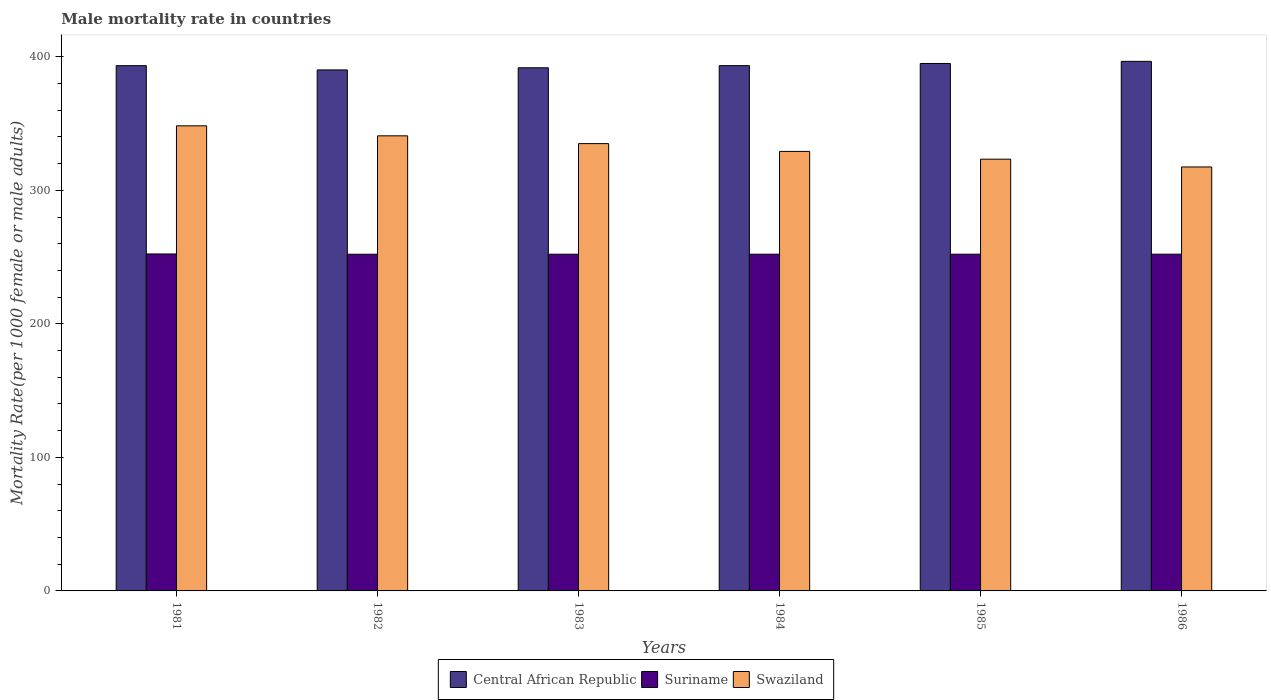How many groups of bars are there?
Offer a very short reply. 6. Are the number of bars on each tick of the X-axis equal?
Provide a succinct answer. Yes. How many bars are there on the 2nd tick from the left?
Your answer should be compact. 3. How many bars are there on the 3rd tick from the right?
Give a very brief answer. 3. What is the male mortality rate in Central African Republic in 1985?
Your response must be concise. 395. Across all years, what is the maximum male mortality rate in Suriname?
Your answer should be very brief. 252.35. Across all years, what is the minimum male mortality rate in Central African Republic?
Provide a succinct answer. 390.2. In which year was the male mortality rate in Suriname minimum?
Offer a terse response. 1982. What is the total male mortality rate in Central African Republic in the graph?
Keep it short and to the point. 2360.39. What is the difference between the male mortality rate in Central African Republic in 1981 and that in 1983?
Ensure brevity in your answer.  1.58. What is the difference between the male mortality rate in Swaziland in 1986 and the male mortality rate in Central African Republic in 1985?
Your answer should be very brief. -77.5. What is the average male mortality rate in Central African Republic per year?
Make the answer very short. 393.4. In the year 1986, what is the difference between the male mortality rate in Swaziland and male mortality rate in Suriname?
Offer a terse response. 65.32. What is the ratio of the male mortality rate in Swaziland in 1981 to that in 1985?
Give a very brief answer. 1.08. Is the male mortality rate in Suriname in 1984 less than that in 1986?
Your answer should be compact. Yes. What is the difference between the highest and the second highest male mortality rate in Swaziland?
Make the answer very short. 7.51. What is the difference between the highest and the lowest male mortality rate in Suriname?
Offer a very short reply. 0.21. Is the sum of the male mortality rate in Central African Republic in 1981 and 1986 greater than the maximum male mortality rate in Suriname across all years?
Ensure brevity in your answer.  Yes. What does the 3rd bar from the left in 1981 represents?
Offer a very short reply. Swaziland. What does the 2nd bar from the right in 1986 represents?
Offer a terse response. Suriname. Are all the bars in the graph horizontal?
Keep it short and to the point. No. How many years are there in the graph?
Provide a short and direct response. 6. How many legend labels are there?
Offer a very short reply. 3. How are the legend labels stacked?
Keep it short and to the point. Horizontal. What is the title of the graph?
Give a very brief answer. Male mortality rate in countries. Does "Senegal" appear as one of the legend labels in the graph?
Offer a very short reply. No. What is the label or title of the Y-axis?
Provide a succinct answer. Mortality Rate(per 1000 female or male adults). What is the Mortality Rate(per 1000 female or male adults) in Central African Republic in 1981?
Ensure brevity in your answer.  393.38. What is the Mortality Rate(per 1000 female or male adults) in Suriname in 1981?
Offer a terse response. 252.35. What is the Mortality Rate(per 1000 female or male adults) in Swaziland in 1981?
Keep it short and to the point. 348.33. What is the Mortality Rate(per 1000 female or male adults) of Central African Republic in 1982?
Your answer should be compact. 390.2. What is the Mortality Rate(per 1000 female or male adults) of Suriname in 1982?
Your answer should be compact. 252.15. What is the Mortality Rate(per 1000 female or male adults) of Swaziland in 1982?
Give a very brief answer. 340.82. What is the Mortality Rate(per 1000 female or male adults) in Central African Republic in 1983?
Offer a very short reply. 391.8. What is the Mortality Rate(per 1000 female or male adults) of Suriname in 1983?
Your answer should be compact. 252.16. What is the Mortality Rate(per 1000 female or male adults) in Swaziland in 1983?
Offer a very short reply. 334.99. What is the Mortality Rate(per 1000 female or male adults) of Central African Republic in 1984?
Your answer should be very brief. 393.4. What is the Mortality Rate(per 1000 female or male adults) in Suriname in 1984?
Your answer should be very brief. 252.17. What is the Mortality Rate(per 1000 female or male adults) in Swaziland in 1984?
Ensure brevity in your answer.  329.16. What is the Mortality Rate(per 1000 female or male adults) in Central African Republic in 1985?
Your answer should be compact. 395. What is the Mortality Rate(per 1000 female or male adults) in Suriname in 1985?
Ensure brevity in your answer.  252.18. What is the Mortality Rate(per 1000 female or male adults) in Swaziland in 1985?
Keep it short and to the point. 323.33. What is the Mortality Rate(per 1000 female or male adults) in Central African Republic in 1986?
Your answer should be very brief. 396.6. What is the Mortality Rate(per 1000 female or male adults) of Suriname in 1986?
Provide a succinct answer. 252.19. What is the Mortality Rate(per 1000 female or male adults) in Swaziland in 1986?
Your response must be concise. 317.51. Across all years, what is the maximum Mortality Rate(per 1000 female or male adults) in Central African Republic?
Offer a very short reply. 396.6. Across all years, what is the maximum Mortality Rate(per 1000 female or male adults) in Suriname?
Your answer should be compact. 252.35. Across all years, what is the maximum Mortality Rate(per 1000 female or male adults) of Swaziland?
Provide a succinct answer. 348.33. Across all years, what is the minimum Mortality Rate(per 1000 female or male adults) of Central African Republic?
Ensure brevity in your answer.  390.2. Across all years, what is the minimum Mortality Rate(per 1000 female or male adults) in Suriname?
Offer a very short reply. 252.15. Across all years, what is the minimum Mortality Rate(per 1000 female or male adults) in Swaziland?
Provide a short and direct response. 317.51. What is the total Mortality Rate(per 1000 female or male adults) of Central African Republic in the graph?
Ensure brevity in your answer.  2360.39. What is the total Mortality Rate(per 1000 female or male adults) in Suriname in the graph?
Make the answer very short. 1513.19. What is the total Mortality Rate(per 1000 female or male adults) in Swaziland in the graph?
Give a very brief answer. 1994.14. What is the difference between the Mortality Rate(per 1000 female or male adults) in Central African Republic in 1981 and that in 1982?
Offer a terse response. 3.18. What is the difference between the Mortality Rate(per 1000 female or male adults) of Suriname in 1981 and that in 1982?
Provide a short and direct response. 0.21. What is the difference between the Mortality Rate(per 1000 female or male adults) of Swaziland in 1981 and that in 1982?
Keep it short and to the point. 7.51. What is the difference between the Mortality Rate(per 1000 female or male adults) in Central African Republic in 1981 and that in 1983?
Keep it short and to the point. 1.58. What is the difference between the Mortality Rate(per 1000 female or male adults) in Suriname in 1981 and that in 1983?
Make the answer very short. 0.2. What is the difference between the Mortality Rate(per 1000 female or male adults) of Swaziland in 1981 and that in 1983?
Your answer should be very brief. 13.34. What is the difference between the Mortality Rate(per 1000 female or male adults) in Central African Republic in 1981 and that in 1984?
Your answer should be compact. -0.02. What is the difference between the Mortality Rate(per 1000 female or male adults) of Suriname in 1981 and that in 1984?
Offer a terse response. 0.19. What is the difference between the Mortality Rate(per 1000 female or male adults) in Swaziland in 1981 and that in 1984?
Offer a terse response. 19.16. What is the difference between the Mortality Rate(per 1000 female or male adults) in Central African Republic in 1981 and that in 1985?
Give a very brief answer. -1.62. What is the difference between the Mortality Rate(per 1000 female or male adults) of Suriname in 1981 and that in 1985?
Offer a terse response. 0.18. What is the difference between the Mortality Rate(per 1000 female or male adults) of Swaziland in 1981 and that in 1985?
Your response must be concise. 24.99. What is the difference between the Mortality Rate(per 1000 female or male adults) of Central African Republic in 1981 and that in 1986?
Your response must be concise. -3.22. What is the difference between the Mortality Rate(per 1000 female or male adults) of Suriname in 1981 and that in 1986?
Provide a succinct answer. 0.17. What is the difference between the Mortality Rate(per 1000 female or male adults) in Swaziland in 1981 and that in 1986?
Give a very brief answer. 30.82. What is the difference between the Mortality Rate(per 1000 female or male adults) of Central African Republic in 1982 and that in 1983?
Your answer should be very brief. -1.6. What is the difference between the Mortality Rate(per 1000 female or male adults) in Suriname in 1982 and that in 1983?
Provide a succinct answer. -0.01. What is the difference between the Mortality Rate(per 1000 female or male adults) of Swaziland in 1982 and that in 1983?
Make the answer very short. 5.83. What is the difference between the Mortality Rate(per 1000 female or male adults) of Central African Republic in 1982 and that in 1984?
Provide a short and direct response. -3.2. What is the difference between the Mortality Rate(per 1000 female or male adults) in Suriname in 1982 and that in 1984?
Offer a terse response. -0.02. What is the difference between the Mortality Rate(per 1000 female or male adults) in Swaziland in 1982 and that in 1984?
Offer a very short reply. 11.66. What is the difference between the Mortality Rate(per 1000 female or male adults) in Central African Republic in 1982 and that in 1985?
Provide a succinct answer. -4.8. What is the difference between the Mortality Rate(per 1000 female or male adults) of Suriname in 1982 and that in 1985?
Offer a terse response. -0.03. What is the difference between the Mortality Rate(per 1000 female or male adults) of Swaziland in 1982 and that in 1985?
Make the answer very short. 17.48. What is the difference between the Mortality Rate(per 1000 female or male adults) of Central African Republic in 1982 and that in 1986?
Offer a terse response. -6.41. What is the difference between the Mortality Rate(per 1000 female or male adults) of Suriname in 1982 and that in 1986?
Ensure brevity in your answer.  -0.04. What is the difference between the Mortality Rate(per 1000 female or male adults) of Swaziland in 1982 and that in 1986?
Offer a very short reply. 23.31. What is the difference between the Mortality Rate(per 1000 female or male adults) of Central African Republic in 1983 and that in 1984?
Ensure brevity in your answer.  -1.6. What is the difference between the Mortality Rate(per 1000 female or male adults) of Suriname in 1983 and that in 1984?
Provide a succinct answer. -0.01. What is the difference between the Mortality Rate(per 1000 female or male adults) in Swaziland in 1983 and that in 1984?
Your response must be concise. 5.83. What is the difference between the Mortality Rate(per 1000 female or male adults) in Central African Republic in 1983 and that in 1985?
Provide a succinct answer. -3.2. What is the difference between the Mortality Rate(per 1000 female or male adults) in Suriname in 1983 and that in 1985?
Provide a short and direct response. -0.02. What is the difference between the Mortality Rate(per 1000 female or male adults) in Swaziland in 1983 and that in 1985?
Keep it short and to the point. 11.65. What is the difference between the Mortality Rate(per 1000 female or male adults) of Central African Republic in 1983 and that in 1986?
Keep it short and to the point. -4.8. What is the difference between the Mortality Rate(per 1000 female or male adults) of Suriname in 1983 and that in 1986?
Make the answer very short. -0.03. What is the difference between the Mortality Rate(per 1000 female or male adults) in Swaziland in 1983 and that in 1986?
Your answer should be very brief. 17.48. What is the difference between the Mortality Rate(per 1000 female or male adults) of Central African Republic in 1984 and that in 1985?
Offer a terse response. -1.6. What is the difference between the Mortality Rate(per 1000 female or male adults) in Suriname in 1984 and that in 1985?
Your answer should be very brief. -0.01. What is the difference between the Mortality Rate(per 1000 female or male adults) in Swaziland in 1984 and that in 1985?
Give a very brief answer. 5.83. What is the difference between the Mortality Rate(per 1000 female or male adults) in Central African Republic in 1984 and that in 1986?
Offer a very short reply. -3.2. What is the difference between the Mortality Rate(per 1000 female or male adults) of Suriname in 1984 and that in 1986?
Offer a very short reply. -0.02. What is the difference between the Mortality Rate(per 1000 female or male adults) of Swaziland in 1984 and that in 1986?
Offer a terse response. 11.65. What is the difference between the Mortality Rate(per 1000 female or male adults) in Central African Republic in 1985 and that in 1986?
Ensure brevity in your answer.  -1.6. What is the difference between the Mortality Rate(per 1000 female or male adults) of Suriname in 1985 and that in 1986?
Make the answer very short. -0.01. What is the difference between the Mortality Rate(per 1000 female or male adults) in Swaziland in 1985 and that in 1986?
Give a very brief answer. 5.83. What is the difference between the Mortality Rate(per 1000 female or male adults) in Central African Republic in 1981 and the Mortality Rate(per 1000 female or male adults) in Suriname in 1982?
Give a very brief answer. 141.24. What is the difference between the Mortality Rate(per 1000 female or male adults) in Central African Republic in 1981 and the Mortality Rate(per 1000 female or male adults) in Swaziland in 1982?
Give a very brief answer. 52.56. What is the difference between the Mortality Rate(per 1000 female or male adults) of Suriname in 1981 and the Mortality Rate(per 1000 female or male adults) of Swaziland in 1982?
Make the answer very short. -88.46. What is the difference between the Mortality Rate(per 1000 female or male adults) of Central African Republic in 1981 and the Mortality Rate(per 1000 female or male adults) of Suriname in 1983?
Your answer should be compact. 141.22. What is the difference between the Mortality Rate(per 1000 female or male adults) of Central African Republic in 1981 and the Mortality Rate(per 1000 female or male adults) of Swaziland in 1983?
Offer a very short reply. 58.39. What is the difference between the Mortality Rate(per 1000 female or male adults) in Suriname in 1981 and the Mortality Rate(per 1000 female or male adults) in Swaziland in 1983?
Keep it short and to the point. -82.64. What is the difference between the Mortality Rate(per 1000 female or male adults) in Central African Republic in 1981 and the Mortality Rate(per 1000 female or male adults) in Suriname in 1984?
Provide a short and direct response. 141.21. What is the difference between the Mortality Rate(per 1000 female or male adults) in Central African Republic in 1981 and the Mortality Rate(per 1000 female or male adults) in Swaziland in 1984?
Provide a succinct answer. 64.22. What is the difference between the Mortality Rate(per 1000 female or male adults) in Suriname in 1981 and the Mortality Rate(per 1000 female or male adults) in Swaziland in 1984?
Provide a short and direct response. -76.81. What is the difference between the Mortality Rate(per 1000 female or male adults) of Central African Republic in 1981 and the Mortality Rate(per 1000 female or male adults) of Suriname in 1985?
Make the answer very short. 141.2. What is the difference between the Mortality Rate(per 1000 female or male adults) in Central African Republic in 1981 and the Mortality Rate(per 1000 female or male adults) in Swaziland in 1985?
Provide a short and direct response. 70.05. What is the difference between the Mortality Rate(per 1000 female or male adults) in Suriname in 1981 and the Mortality Rate(per 1000 female or male adults) in Swaziland in 1985?
Your answer should be very brief. -70.98. What is the difference between the Mortality Rate(per 1000 female or male adults) in Central African Republic in 1981 and the Mortality Rate(per 1000 female or male adults) in Suriname in 1986?
Your answer should be compact. 141.19. What is the difference between the Mortality Rate(per 1000 female or male adults) of Central African Republic in 1981 and the Mortality Rate(per 1000 female or male adults) of Swaziland in 1986?
Keep it short and to the point. 75.87. What is the difference between the Mortality Rate(per 1000 female or male adults) in Suriname in 1981 and the Mortality Rate(per 1000 female or male adults) in Swaziland in 1986?
Ensure brevity in your answer.  -65.15. What is the difference between the Mortality Rate(per 1000 female or male adults) in Central African Republic in 1982 and the Mortality Rate(per 1000 female or male adults) in Suriname in 1983?
Keep it short and to the point. 138.04. What is the difference between the Mortality Rate(per 1000 female or male adults) of Central African Republic in 1982 and the Mortality Rate(per 1000 female or male adults) of Swaziland in 1983?
Offer a terse response. 55.21. What is the difference between the Mortality Rate(per 1000 female or male adults) of Suriname in 1982 and the Mortality Rate(per 1000 female or male adults) of Swaziland in 1983?
Your answer should be very brief. -82.84. What is the difference between the Mortality Rate(per 1000 female or male adults) of Central African Republic in 1982 and the Mortality Rate(per 1000 female or male adults) of Suriname in 1984?
Give a very brief answer. 138.03. What is the difference between the Mortality Rate(per 1000 female or male adults) in Central African Republic in 1982 and the Mortality Rate(per 1000 female or male adults) in Swaziland in 1984?
Make the answer very short. 61.04. What is the difference between the Mortality Rate(per 1000 female or male adults) in Suriname in 1982 and the Mortality Rate(per 1000 female or male adults) in Swaziland in 1984?
Make the answer very short. -77.02. What is the difference between the Mortality Rate(per 1000 female or male adults) of Central African Republic in 1982 and the Mortality Rate(per 1000 female or male adults) of Suriname in 1985?
Offer a terse response. 138.02. What is the difference between the Mortality Rate(per 1000 female or male adults) in Central African Republic in 1982 and the Mortality Rate(per 1000 female or male adults) in Swaziland in 1985?
Offer a very short reply. 66.86. What is the difference between the Mortality Rate(per 1000 female or male adults) in Suriname in 1982 and the Mortality Rate(per 1000 female or male adults) in Swaziland in 1985?
Provide a short and direct response. -71.19. What is the difference between the Mortality Rate(per 1000 female or male adults) of Central African Republic in 1982 and the Mortality Rate(per 1000 female or male adults) of Suriname in 1986?
Make the answer very short. 138.01. What is the difference between the Mortality Rate(per 1000 female or male adults) of Central African Republic in 1982 and the Mortality Rate(per 1000 female or male adults) of Swaziland in 1986?
Provide a short and direct response. 72.69. What is the difference between the Mortality Rate(per 1000 female or male adults) in Suriname in 1982 and the Mortality Rate(per 1000 female or male adults) in Swaziland in 1986?
Give a very brief answer. -65.36. What is the difference between the Mortality Rate(per 1000 female or male adults) in Central African Republic in 1983 and the Mortality Rate(per 1000 female or male adults) in Suriname in 1984?
Provide a succinct answer. 139.63. What is the difference between the Mortality Rate(per 1000 female or male adults) in Central African Republic in 1983 and the Mortality Rate(per 1000 female or male adults) in Swaziland in 1984?
Ensure brevity in your answer.  62.64. What is the difference between the Mortality Rate(per 1000 female or male adults) of Suriname in 1983 and the Mortality Rate(per 1000 female or male adults) of Swaziland in 1984?
Keep it short and to the point. -77. What is the difference between the Mortality Rate(per 1000 female or male adults) in Central African Republic in 1983 and the Mortality Rate(per 1000 female or male adults) in Suriname in 1985?
Provide a short and direct response. 139.62. What is the difference between the Mortality Rate(per 1000 female or male adults) of Central African Republic in 1983 and the Mortality Rate(per 1000 female or male adults) of Swaziland in 1985?
Give a very brief answer. 68.47. What is the difference between the Mortality Rate(per 1000 female or male adults) of Suriname in 1983 and the Mortality Rate(per 1000 female or male adults) of Swaziland in 1985?
Make the answer very short. -71.18. What is the difference between the Mortality Rate(per 1000 female or male adults) of Central African Republic in 1983 and the Mortality Rate(per 1000 female or male adults) of Suriname in 1986?
Your answer should be compact. 139.61. What is the difference between the Mortality Rate(per 1000 female or male adults) of Central African Republic in 1983 and the Mortality Rate(per 1000 female or male adults) of Swaziland in 1986?
Offer a terse response. 74.29. What is the difference between the Mortality Rate(per 1000 female or male adults) of Suriname in 1983 and the Mortality Rate(per 1000 female or male adults) of Swaziland in 1986?
Make the answer very short. -65.35. What is the difference between the Mortality Rate(per 1000 female or male adults) of Central African Republic in 1984 and the Mortality Rate(per 1000 female or male adults) of Suriname in 1985?
Give a very brief answer. 141.22. What is the difference between the Mortality Rate(per 1000 female or male adults) in Central African Republic in 1984 and the Mortality Rate(per 1000 female or male adults) in Swaziland in 1985?
Provide a succinct answer. 70.07. What is the difference between the Mortality Rate(per 1000 female or male adults) of Suriname in 1984 and the Mortality Rate(per 1000 female or male adults) of Swaziland in 1985?
Give a very brief answer. -71.17. What is the difference between the Mortality Rate(per 1000 female or male adults) of Central African Republic in 1984 and the Mortality Rate(per 1000 female or male adults) of Suriname in 1986?
Your response must be concise. 141.21. What is the difference between the Mortality Rate(per 1000 female or male adults) in Central African Republic in 1984 and the Mortality Rate(per 1000 female or male adults) in Swaziland in 1986?
Provide a short and direct response. 75.89. What is the difference between the Mortality Rate(per 1000 female or male adults) in Suriname in 1984 and the Mortality Rate(per 1000 female or male adults) in Swaziland in 1986?
Give a very brief answer. -65.34. What is the difference between the Mortality Rate(per 1000 female or male adults) of Central African Republic in 1985 and the Mortality Rate(per 1000 female or male adults) of Suriname in 1986?
Give a very brief answer. 142.81. What is the difference between the Mortality Rate(per 1000 female or male adults) in Central African Republic in 1985 and the Mortality Rate(per 1000 female or male adults) in Swaziland in 1986?
Offer a very short reply. 77.5. What is the difference between the Mortality Rate(per 1000 female or male adults) in Suriname in 1985 and the Mortality Rate(per 1000 female or male adults) in Swaziland in 1986?
Your answer should be very brief. -65.33. What is the average Mortality Rate(per 1000 female or male adults) of Central African Republic per year?
Offer a terse response. 393.4. What is the average Mortality Rate(per 1000 female or male adults) in Suriname per year?
Provide a short and direct response. 252.2. What is the average Mortality Rate(per 1000 female or male adults) of Swaziland per year?
Your answer should be very brief. 332.36. In the year 1981, what is the difference between the Mortality Rate(per 1000 female or male adults) in Central African Republic and Mortality Rate(per 1000 female or male adults) in Suriname?
Make the answer very short. 141.03. In the year 1981, what is the difference between the Mortality Rate(per 1000 female or male adults) of Central African Republic and Mortality Rate(per 1000 female or male adults) of Swaziland?
Your answer should be very brief. 45.05. In the year 1981, what is the difference between the Mortality Rate(per 1000 female or male adults) of Suriname and Mortality Rate(per 1000 female or male adults) of Swaziland?
Give a very brief answer. -95.97. In the year 1982, what is the difference between the Mortality Rate(per 1000 female or male adults) in Central African Republic and Mortality Rate(per 1000 female or male adults) in Suriname?
Give a very brief answer. 138.05. In the year 1982, what is the difference between the Mortality Rate(per 1000 female or male adults) in Central African Republic and Mortality Rate(per 1000 female or male adults) in Swaziland?
Keep it short and to the point. 49.38. In the year 1982, what is the difference between the Mortality Rate(per 1000 female or male adults) of Suriname and Mortality Rate(per 1000 female or male adults) of Swaziland?
Your answer should be very brief. -88.67. In the year 1983, what is the difference between the Mortality Rate(per 1000 female or male adults) in Central African Republic and Mortality Rate(per 1000 female or male adults) in Suriname?
Provide a succinct answer. 139.64. In the year 1983, what is the difference between the Mortality Rate(per 1000 female or male adults) of Central African Republic and Mortality Rate(per 1000 female or male adults) of Swaziland?
Offer a very short reply. 56.81. In the year 1983, what is the difference between the Mortality Rate(per 1000 female or male adults) in Suriname and Mortality Rate(per 1000 female or male adults) in Swaziland?
Ensure brevity in your answer.  -82.83. In the year 1984, what is the difference between the Mortality Rate(per 1000 female or male adults) in Central African Republic and Mortality Rate(per 1000 female or male adults) in Suriname?
Keep it short and to the point. 141.23. In the year 1984, what is the difference between the Mortality Rate(per 1000 female or male adults) in Central African Republic and Mortality Rate(per 1000 female or male adults) in Swaziland?
Your response must be concise. 64.24. In the year 1984, what is the difference between the Mortality Rate(per 1000 female or male adults) in Suriname and Mortality Rate(per 1000 female or male adults) in Swaziland?
Provide a succinct answer. -77. In the year 1985, what is the difference between the Mortality Rate(per 1000 female or male adults) in Central African Republic and Mortality Rate(per 1000 female or male adults) in Suriname?
Give a very brief answer. 142.83. In the year 1985, what is the difference between the Mortality Rate(per 1000 female or male adults) of Central African Republic and Mortality Rate(per 1000 female or male adults) of Swaziland?
Provide a succinct answer. 71.67. In the year 1985, what is the difference between the Mortality Rate(per 1000 female or male adults) of Suriname and Mortality Rate(per 1000 female or male adults) of Swaziland?
Your response must be concise. -71.16. In the year 1986, what is the difference between the Mortality Rate(per 1000 female or male adults) of Central African Republic and Mortality Rate(per 1000 female or male adults) of Suriname?
Keep it short and to the point. 144.42. In the year 1986, what is the difference between the Mortality Rate(per 1000 female or male adults) in Central African Republic and Mortality Rate(per 1000 female or male adults) in Swaziland?
Give a very brief answer. 79.1. In the year 1986, what is the difference between the Mortality Rate(per 1000 female or male adults) in Suriname and Mortality Rate(per 1000 female or male adults) in Swaziland?
Your response must be concise. -65.32. What is the ratio of the Mortality Rate(per 1000 female or male adults) in Central African Republic in 1981 to that in 1982?
Offer a very short reply. 1.01. What is the ratio of the Mortality Rate(per 1000 female or male adults) of Swaziland in 1981 to that in 1982?
Your response must be concise. 1.02. What is the ratio of the Mortality Rate(per 1000 female or male adults) in Swaziland in 1981 to that in 1983?
Provide a succinct answer. 1.04. What is the ratio of the Mortality Rate(per 1000 female or male adults) of Swaziland in 1981 to that in 1984?
Give a very brief answer. 1.06. What is the ratio of the Mortality Rate(per 1000 female or male adults) of Suriname in 1981 to that in 1985?
Provide a succinct answer. 1. What is the ratio of the Mortality Rate(per 1000 female or male adults) in Swaziland in 1981 to that in 1985?
Make the answer very short. 1.08. What is the ratio of the Mortality Rate(per 1000 female or male adults) in Central African Republic in 1981 to that in 1986?
Your response must be concise. 0.99. What is the ratio of the Mortality Rate(per 1000 female or male adults) in Swaziland in 1981 to that in 1986?
Give a very brief answer. 1.1. What is the ratio of the Mortality Rate(per 1000 female or male adults) of Swaziland in 1982 to that in 1983?
Provide a succinct answer. 1.02. What is the ratio of the Mortality Rate(per 1000 female or male adults) of Suriname in 1982 to that in 1984?
Offer a terse response. 1. What is the ratio of the Mortality Rate(per 1000 female or male adults) of Swaziland in 1982 to that in 1984?
Your response must be concise. 1.04. What is the ratio of the Mortality Rate(per 1000 female or male adults) in Central African Republic in 1982 to that in 1985?
Provide a short and direct response. 0.99. What is the ratio of the Mortality Rate(per 1000 female or male adults) of Swaziland in 1982 to that in 1985?
Offer a very short reply. 1.05. What is the ratio of the Mortality Rate(per 1000 female or male adults) in Central African Republic in 1982 to that in 1986?
Give a very brief answer. 0.98. What is the ratio of the Mortality Rate(per 1000 female or male adults) of Swaziland in 1982 to that in 1986?
Ensure brevity in your answer.  1.07. What is the ratio of the Mortality Rate(per 1000 female or male adults) in Suriname in 1983 to that in 1984?
Keep it short and to the point. 1. What is the ratio of the Mortality Rate(per 1000 female or male adults) of Swaziland in 1983 to that in 1984?
Ensure brevity in your answer.  1.02. What is the ratio of the Mortality Rate(per 1000 female or male adults) of Central African Republic in 1983 to that in 1985?
Your answer should be compact. 0.99. What is the ratio of the Mortality Rate(per 1000 female or male adults) in Swaziland in 1983 to that in 1985?
Your answer should be compact. 1.04. What is the ratio of the Mortality Rate(per 1000 female or male adults) in Central African Republic in 1983 to that in 1986?
Your answer should be compact. 0.99. What is the ratio of the Mortality Rate(per 1000 female or male adults) in Swaziland in 1983 to that in 1986?
Keep it short and to the point. 1.06. What is the ratio of the Mortality Rate(per 1000 female or male adults) of Central African Republic in 1984 to that in 1985?
Give a very brief answer. 1. What is the ratio of the Mortality Rate(per 1000 female or male adults) in Swaziland in 1984 to that in 1985?
Keep it short and to the point. 1.02. What is the ratio of the Mortality Rate(per 1000 female or male adults) of Central African Republic in 1984 to that in 1986?
Offer a terse response. 0.99. What is the ratio of the Mortality Rate(per 1000 female or male adults) in Swaziland in 1984 to that in 1986?
Give a very brief answer. 1.04. What is the ratio of the Mortality Rate(per 1000 female or male adults) in Central African Republic in 1985 to that in 1986?
Keep it short and to the point. 1. What is the ratio of the Mortality Rate(per 1000 female or male adults) of Suriname in 1985 to that in 1986?
Give a very brief answer. 1. What is the ratio of the Mortality Rate(per 1000 female or male adults) of Swaziland in 1985 to that in 1986?
Offer a terse response. 1.02. What is the difference between the highest and the second highest Mortality Rate(per 1000 female or male adults) in Central African Republic?
Your response must be concise. 1.6. What is the difference between the highest and the second highest Mortality Rate(per 1000 female or male adults) of Suriname?
Provide a succinct answer. 0.17. What is the difference between the highest and the second highest Mortality Rate(per 1000 female or male adults) of Swaziland?
Make the answer very short. 7.51. What is the difference between the highest and the lowest Mortality Rate(per 1000 female or male adults) of Central African Republic?
Make the answer very short. 6.41. What is the difference between the highest and the lowest Mortality Rate(per 1000 female or male adults) of Suriname?
Provide a succinct answer. 0.21. What is the difference between the highest and the lowest Mortality Rate(per 1000 female or male adults) in Swaziland?
Your answer should be compact. 30.82. 